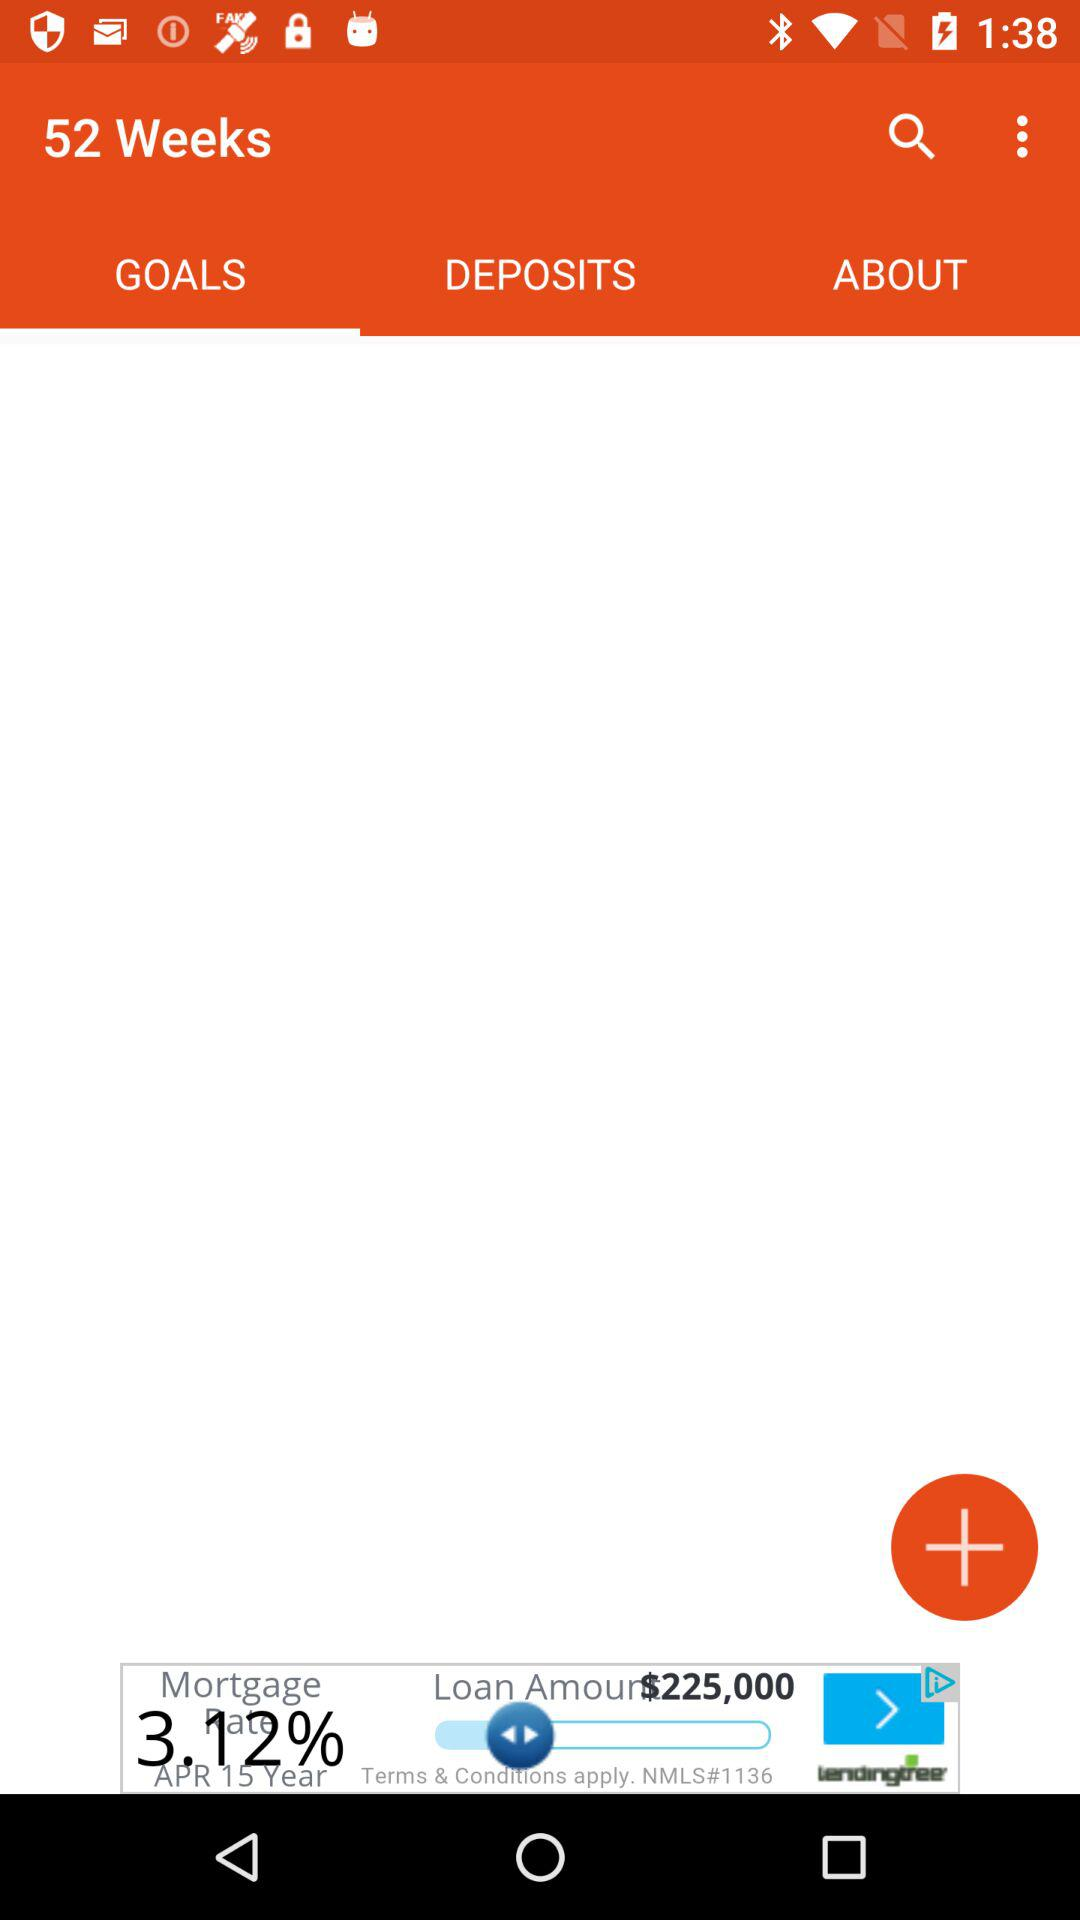Which tab has been selected? The selected tab is "GOALS". 